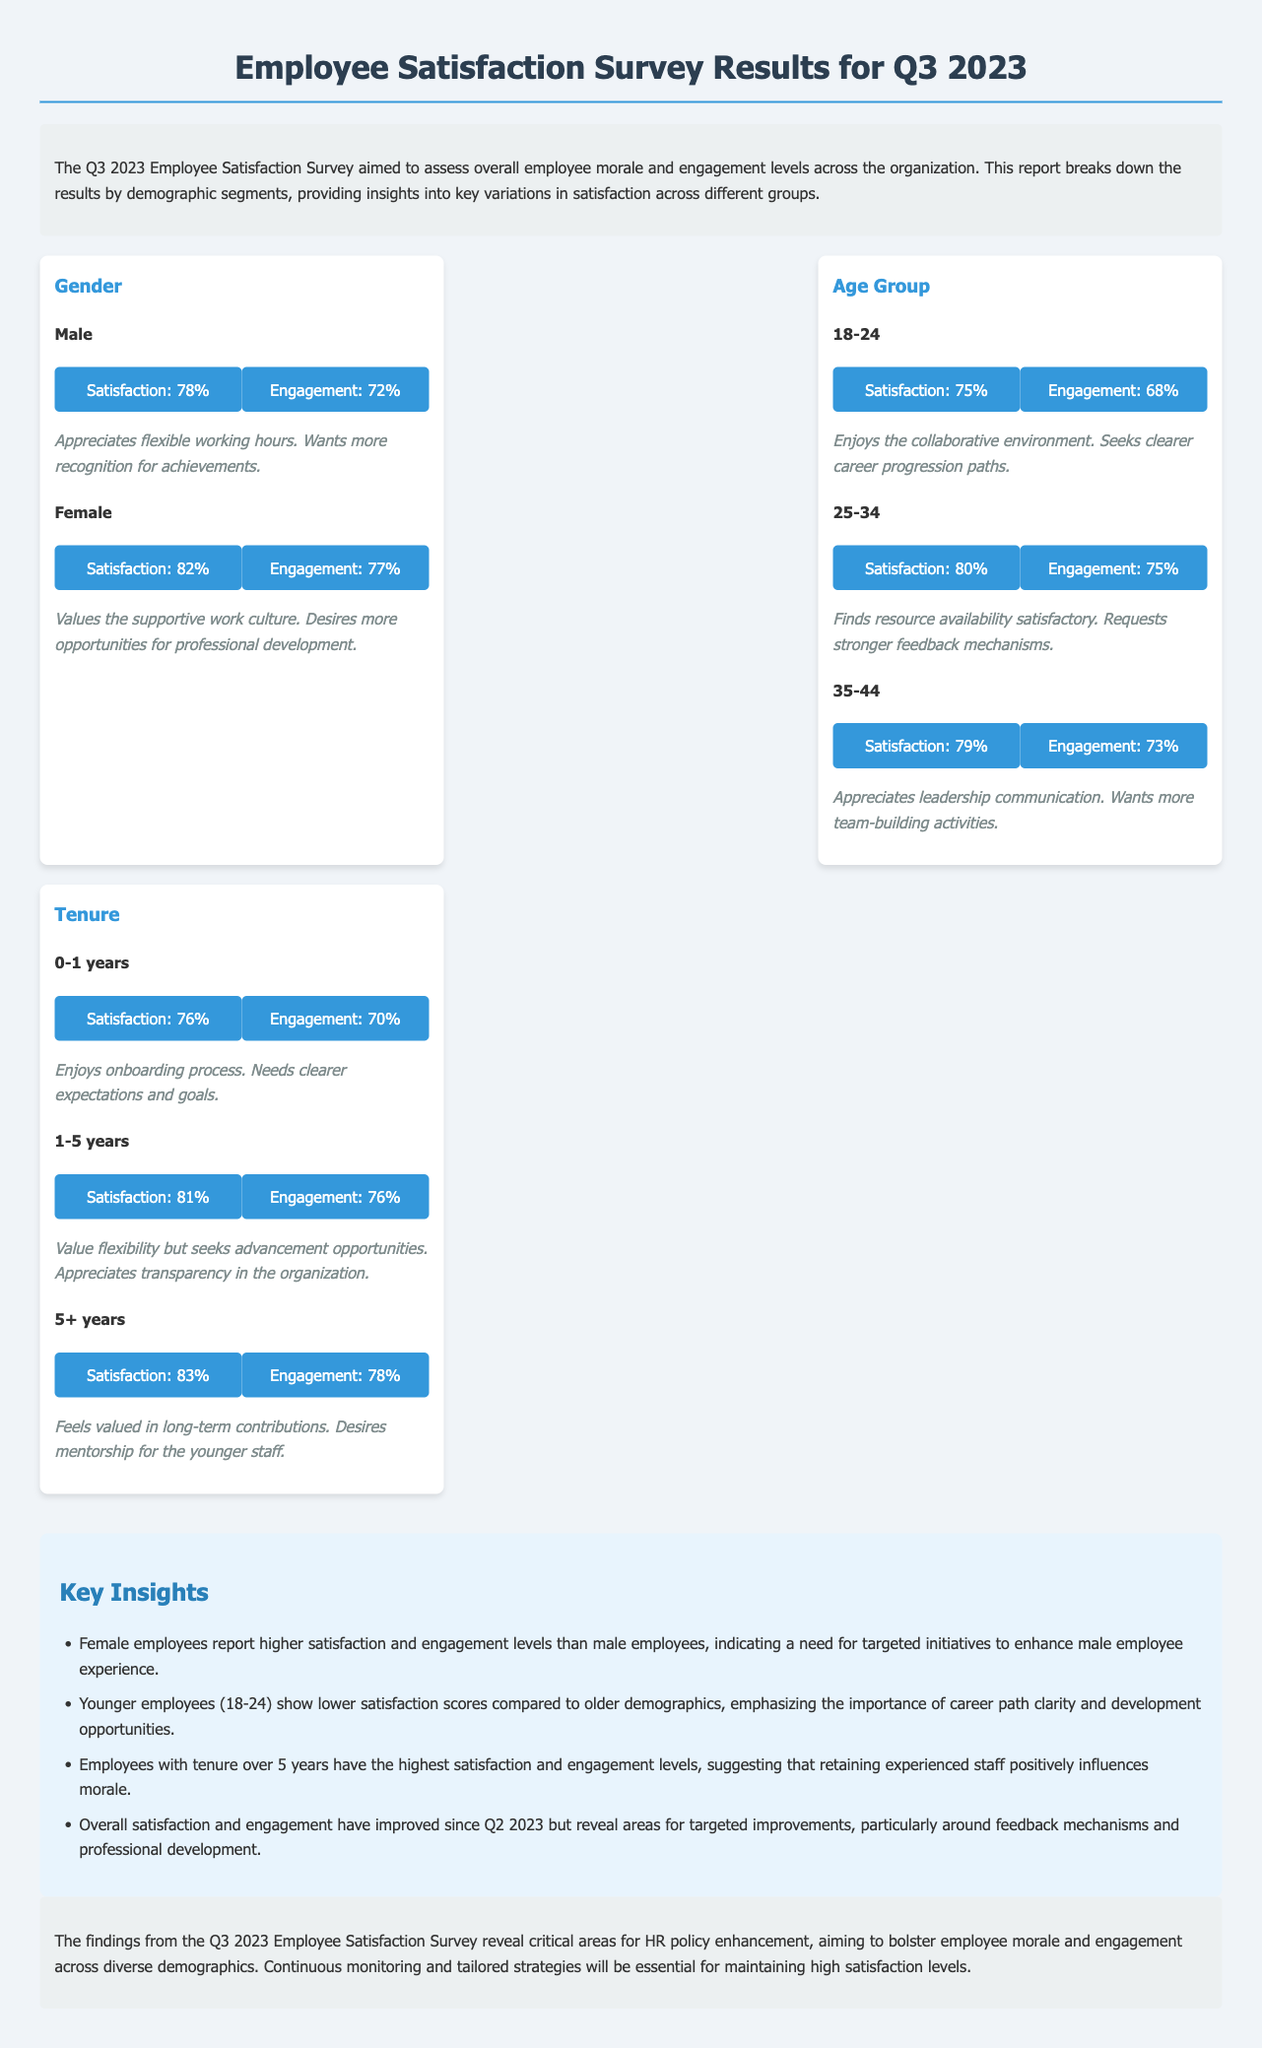what was the overall employee satisfaction score for female employees? The document states that female employees have a satisfaction score of 82%.
Answer: 82% what is the engagement score for male employees? The document indicates that male employees have an engagement score of 72%.
Answer: 72% which age group reported the lowest satisfaction score? The satisfaction score for the age group 18-24 is the lowest at 75%.
Answer: 18-24 what percentage of employees with more than 5 years of tenure reported high satisfaction? Employees with over 5 years of tenure have a satisfaction score of 83%.
Answer: 83% what do younger employees desire more of, according to their comments? Younger employees seek clearer career progression paths.
Answer: clearer career progression paths how does the satisfaction and engagement of employees with less than 1 year of tenure compare to those with 1-5 years of tenure? Employees with 0-1 years have lower satisfaction and engagement than those with 1-5 years (76% vs. 81%).
Answer: lower what key insight suggests a need for targeted initiatives? The insight mentions that female employees report higher satisfaction than male employees.
Answer: targeted initiatives how has overall satisfaction changed since Q2 2023? The document states that overall satisfaction has improved since Q2 2023.
Answer: improved 